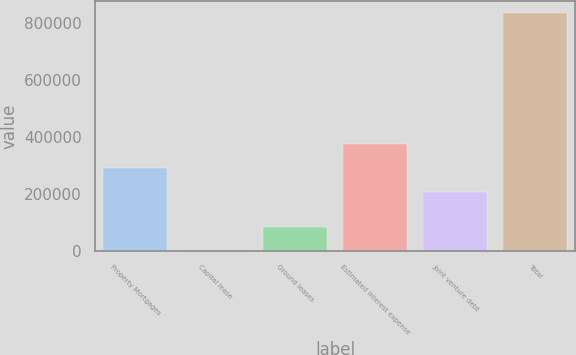Convert chart. <chart><loc_0><loc_0><loc_500><loc_500><bar_chart><fcel>Property Mortgages<fcel>Capital lease<fcel>Ground leases<fcel>Estimated interest expense<fcel>Joint venture debt<fcel>Total<nl><fcel>291073<fcel>1555<fcel>84889.7<fcel>374407<fcel>207738<fcel>834902<nl></chart> 